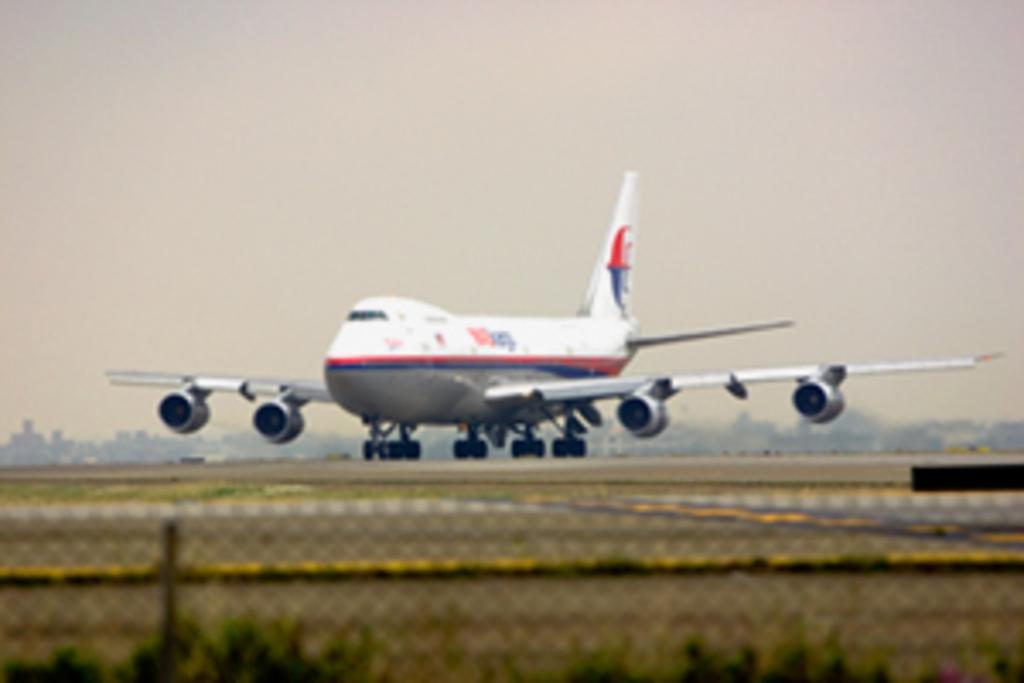In one or two sentences, can you explain what this image depicts? In this image in the center there is one airplane, and at the bottom there is road plants and net. In the background there are some objects, at the top of the mage there is sky. 